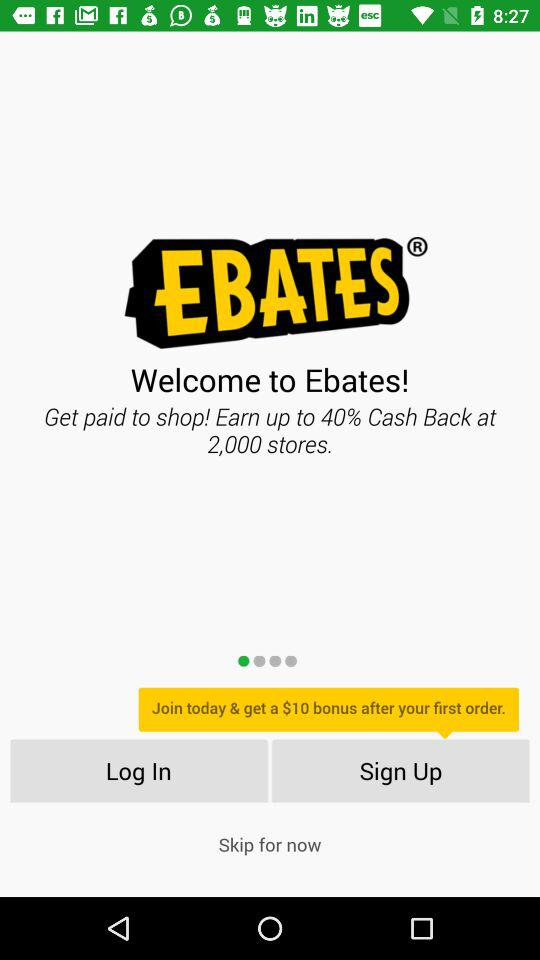How much cash back can I earn at 2,000 stores?
Answer the question using a single word or phrase. Up to 40% 